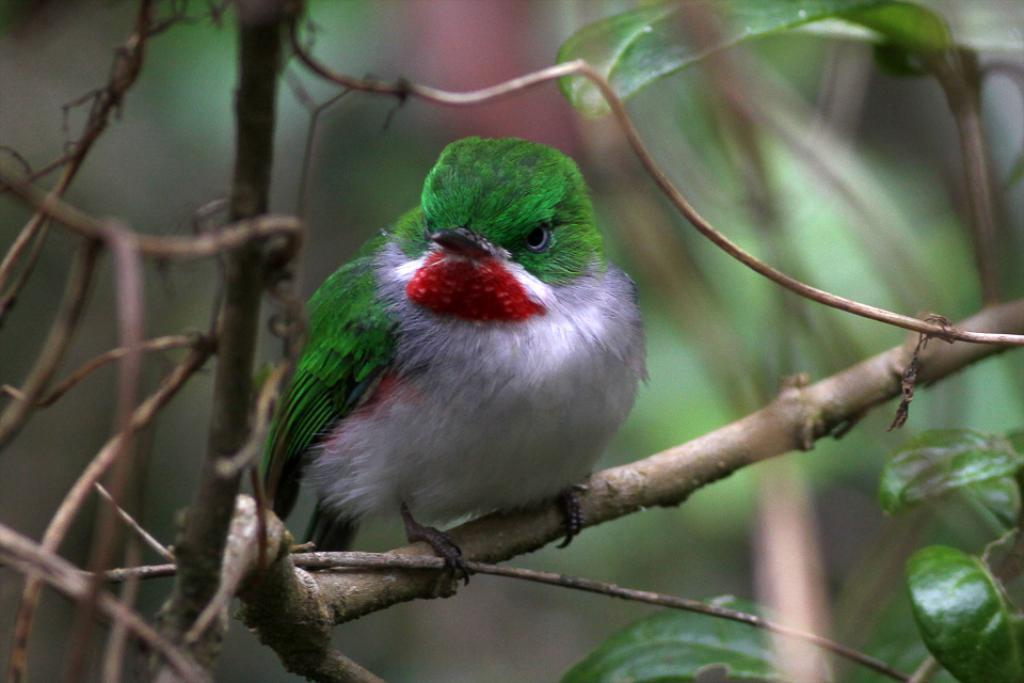What type of animal is in the image? There is a bird in the image. Where is the bird located? The bird is on a tree branch. What can be seen on the right side of the image? There are leaves on the right side of the image. How would you describe the background of the image? The background of the image is blurred. What type of drum can be seen in the image? There is no drum present in the image; it features a bird on a tree branch. 